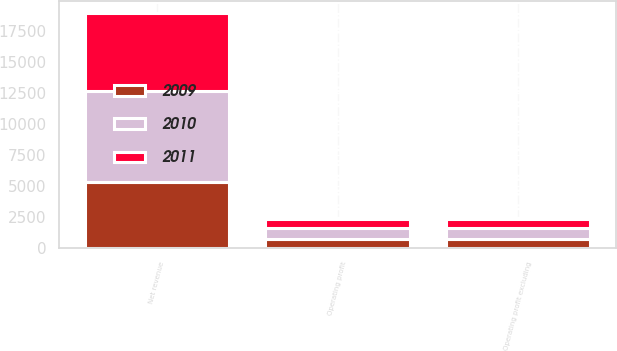<chart> <loc_0><loc_0><loc_500><loc_500><stacked_bar_chart><ecel><fcel>Net revenue<fcel>Operating profit<fcel>Operating profit excluding<nl><fcel>2010<fcel>7392<fcel>887<fcel>896<nl><fcel>2011<fcel>6291<fcel>708<fcel>708<nl><fcel>2009<fcel>5277<fcel>700<fcel>712<nl></chart> 